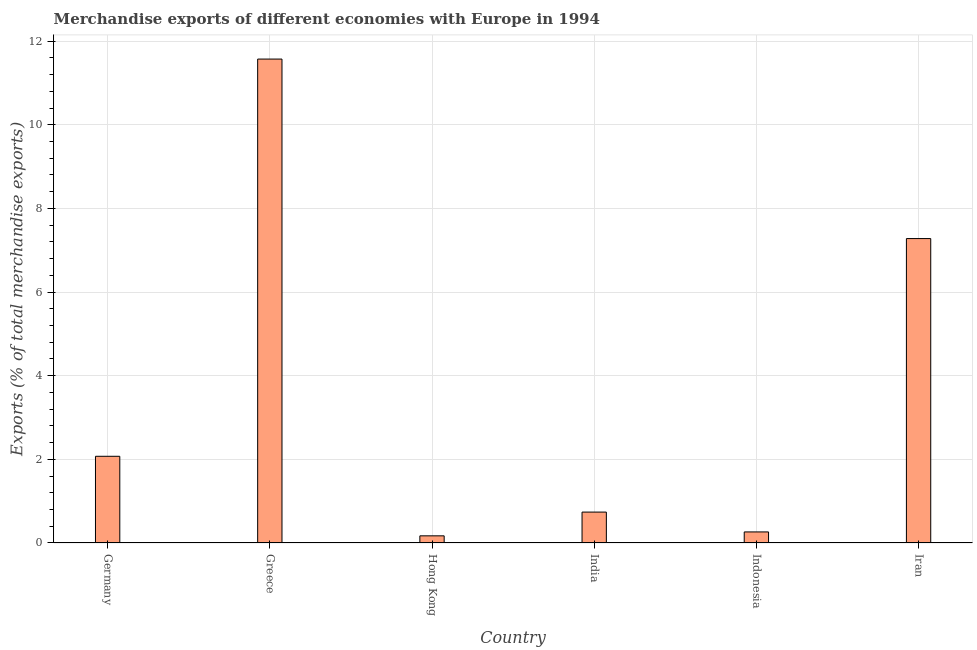Does the graph contain grids?
Your answer should be compact. Yes. What is the title of the graph?
Provide a succinct answer. Merchandise exports of different economies with Europe in 1994. What is the label or title of the Y-axis?
Provide a short and direct response. Exports (% of total merchandise exports). What is the merchandise exports in Hong Kong?
Your answer should be compact. 0.17. Across all countries, what is the maximum merchandise exports?
Make the answer very short. 11.57. Across all countries, what is the minimum merchandise exports?
Ensure brevity in your answer.  0.17. In which country was the merchandise exports maximum?
Ensure brevity in your answer.  Greece. In which country was the merchandise exports minimum?
Your response must be concise. Hong Kong. What is the sum of the merchandise exports?
Make the answer very short. 22.1. What is the difference between the merchandise exports in India and Indonesia?
Provide a short and direct response. 0.47. What is the average merchandise exports per country?
Your response must be concise. 3.68. What is the median merchandise exports?
Your answer should be very brief. 1.41. What is the ratio of the merchandise exports in Germany to that in Iran?
Keep it short and to the point. 0.28. Is the difference between the merchandise exports in Hong Kong and Indonesia greater than the difference between any two countries?
Give a very brief answer. No. What is the difference between the highest and the second highest merchandise exports?
Make the answer very short. 4.29. Is the sum of the merchandise exports in Greece and Hong Kong greater than the maximum merchandise exports across all countries?
Your answer should be compact. Yes. How many bars are there?
Ensure brevity in your answer.  6. Are all the bars in the graph horizontal?
Keep it short and to the point. No. What is the difference between two consecutive major ticks on the Y-axis?
Keep it short and to the point. 2. Are the values on the major ticks of Y-axis written in scientific E-notation?
Your response must be concise. No. What is the Exports (% of total merchandise exports) in Germany?
Offer a very short reply. 2.07. What is the Exports (% of total merchandise exports) in Greece?
Give a very brief answer. 11.57. What is the Exports (% of total merchandise exports) in Hong Kong?
Your response must be concise. 0.17. What is the Exports (% of total merchandise exports) of India?
Make the answer very short. 0.74. What is the Exports (% of total merchandise exports) in Indonesia?
Your answer should be compact. 0.26. What is the Exports (% of total merchandise exports) in Iran?
Your answer should be very brief. 7.28. What is the difference between the Exports (% of total merchandise exports) in Germany and Greece?
Give a very brief answer. -9.5. What is the difference between the Exports (% of total merchandise exports) in Germany and Hong Kong?
Ensure brevity in your answer.  1.9. What is the difference between the Exports (% of total merchandise exports) in Germany and India?
Provide a short and direct response. 1.33. What is the difference between the Exports (% of total merchandise exports) in Germany and Indonesia?
Keep it short and to the point. 1.81. What is the difference between the Exports (% of total merchandise exports) in Germany and Iran?
Offer a very short reply. -5.21. What is the difference between the Exports (% of total merchandise exports) in Greece and Hong Kong?
Make the answer very short. 11.4. What is the difference between the Exports (% of total merchandise exports) in Greece and India?
Ensure brevity in your answer.  10.83. What is the difference between the Exports (% of total merchandise exports) in Greece and Indonesia?
Offer a terse response. 11.31. What is the difference between the Exports (% of total merchandise exports) in Greece and Iran?
Your answer should be compact. 4.29. What is the difference between the Exports (% of total merchandise exports) in Hong Kong and India?
Give a very brief answer. -0.57. What is the difference between the Exports (% of total merchandise exports) in Hong Kong and Indonesia?
Your response must be concise. -0.09. What is the difference between the Exports (% of total merchandise exports) in Hong Kong and Iran?
Keep it short and to the point. -7.11. What is the difference between the Exports (% of total merchandise exports) in India and Indonesia?
Your answer should be compact. 0.47. What is the difference between the Exports (% of total merchandise exports) in India and Iran?
Your response must be concise. -6.54. What is the difference between the Exports (% of total merchandise exports) in Indonesia and Iran?
Provide a succinct answer. -7.01. What is the ratio of the Exports (% of total merchandise exports) in Germany to that in Greece?
Offer a terse response. 0.18. What is the ratio of the Exports (% of total merchandise exports) in Germany to that in Hong Kong?
Your response must be concise. 12.13. What is the ratio of the Exports (% of total merchandise exports) in Germany to that in India?
Offer a terse response. 2.81. What is the ratio of the Exports (% of total merchandise exports) in Germany to that in Indonesia?
Your answer should be compact. 7.83. What is the ratio of the Exports (% of total merchandise exports) in Germany to that in Iran?
Provide a succinct answer. 0.28. What is the ratio of the Exports (% of total merchandise exports) in Greece to that in Hong Kong?
Make the answer very short. 67.69. What is the ratio of the Exports (% of total merchandise exports) in Greece to that in India?
Provide a short and direct response. 15.66. What is the ratio of the Exports (% of total merchandise exports) in Greece to that in Indonesia?
Make the answer very short. 43.73. What is the ratio of the Exports (% of total merchandise exports) in Greece to that in Iran?
Provide a succinct answer. 1.59. What is the ratio of the Exports (% of total merchandise exports) in Hong Kong to that in India?
Give a very brief answer. 0.23. What is the ratio of the Exports (% of total merchandise exports) in Hong Kong to that in Indonesia?
Keep it short and to the point. 0.65. What is the ratio of the Exports (% of total merchandise exports) in Hong Kong to that in Iran?
Ensure brevity in your answer.  0.02. What is the ratio of the Exports (% of total merchandise exports) in India to that in Indonesia?
Provide a succinct answer. 2.79. What is the ratio of the Exports (% of total merchandise exports) in India to that in Iran?
Your response must be concise. 0.1. What is the ratio of the Exports (% of total merchandise exports) in Indonesia to that in Iran?
Your answer should be compact. 0.04. 